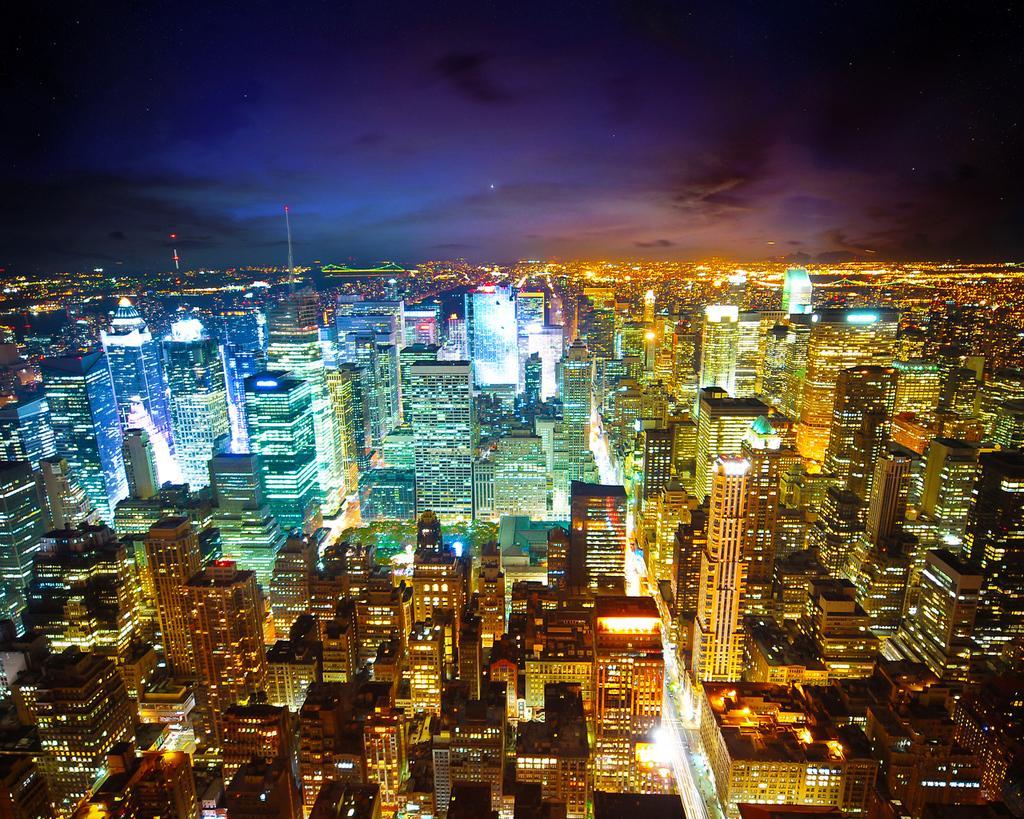How would you summarize this image in a sentence or two? This picture is clicked outside. In the center we can see there are many number of buildings and skyscrapers and we can see the lights. In the background there is a sky and some other objects. 